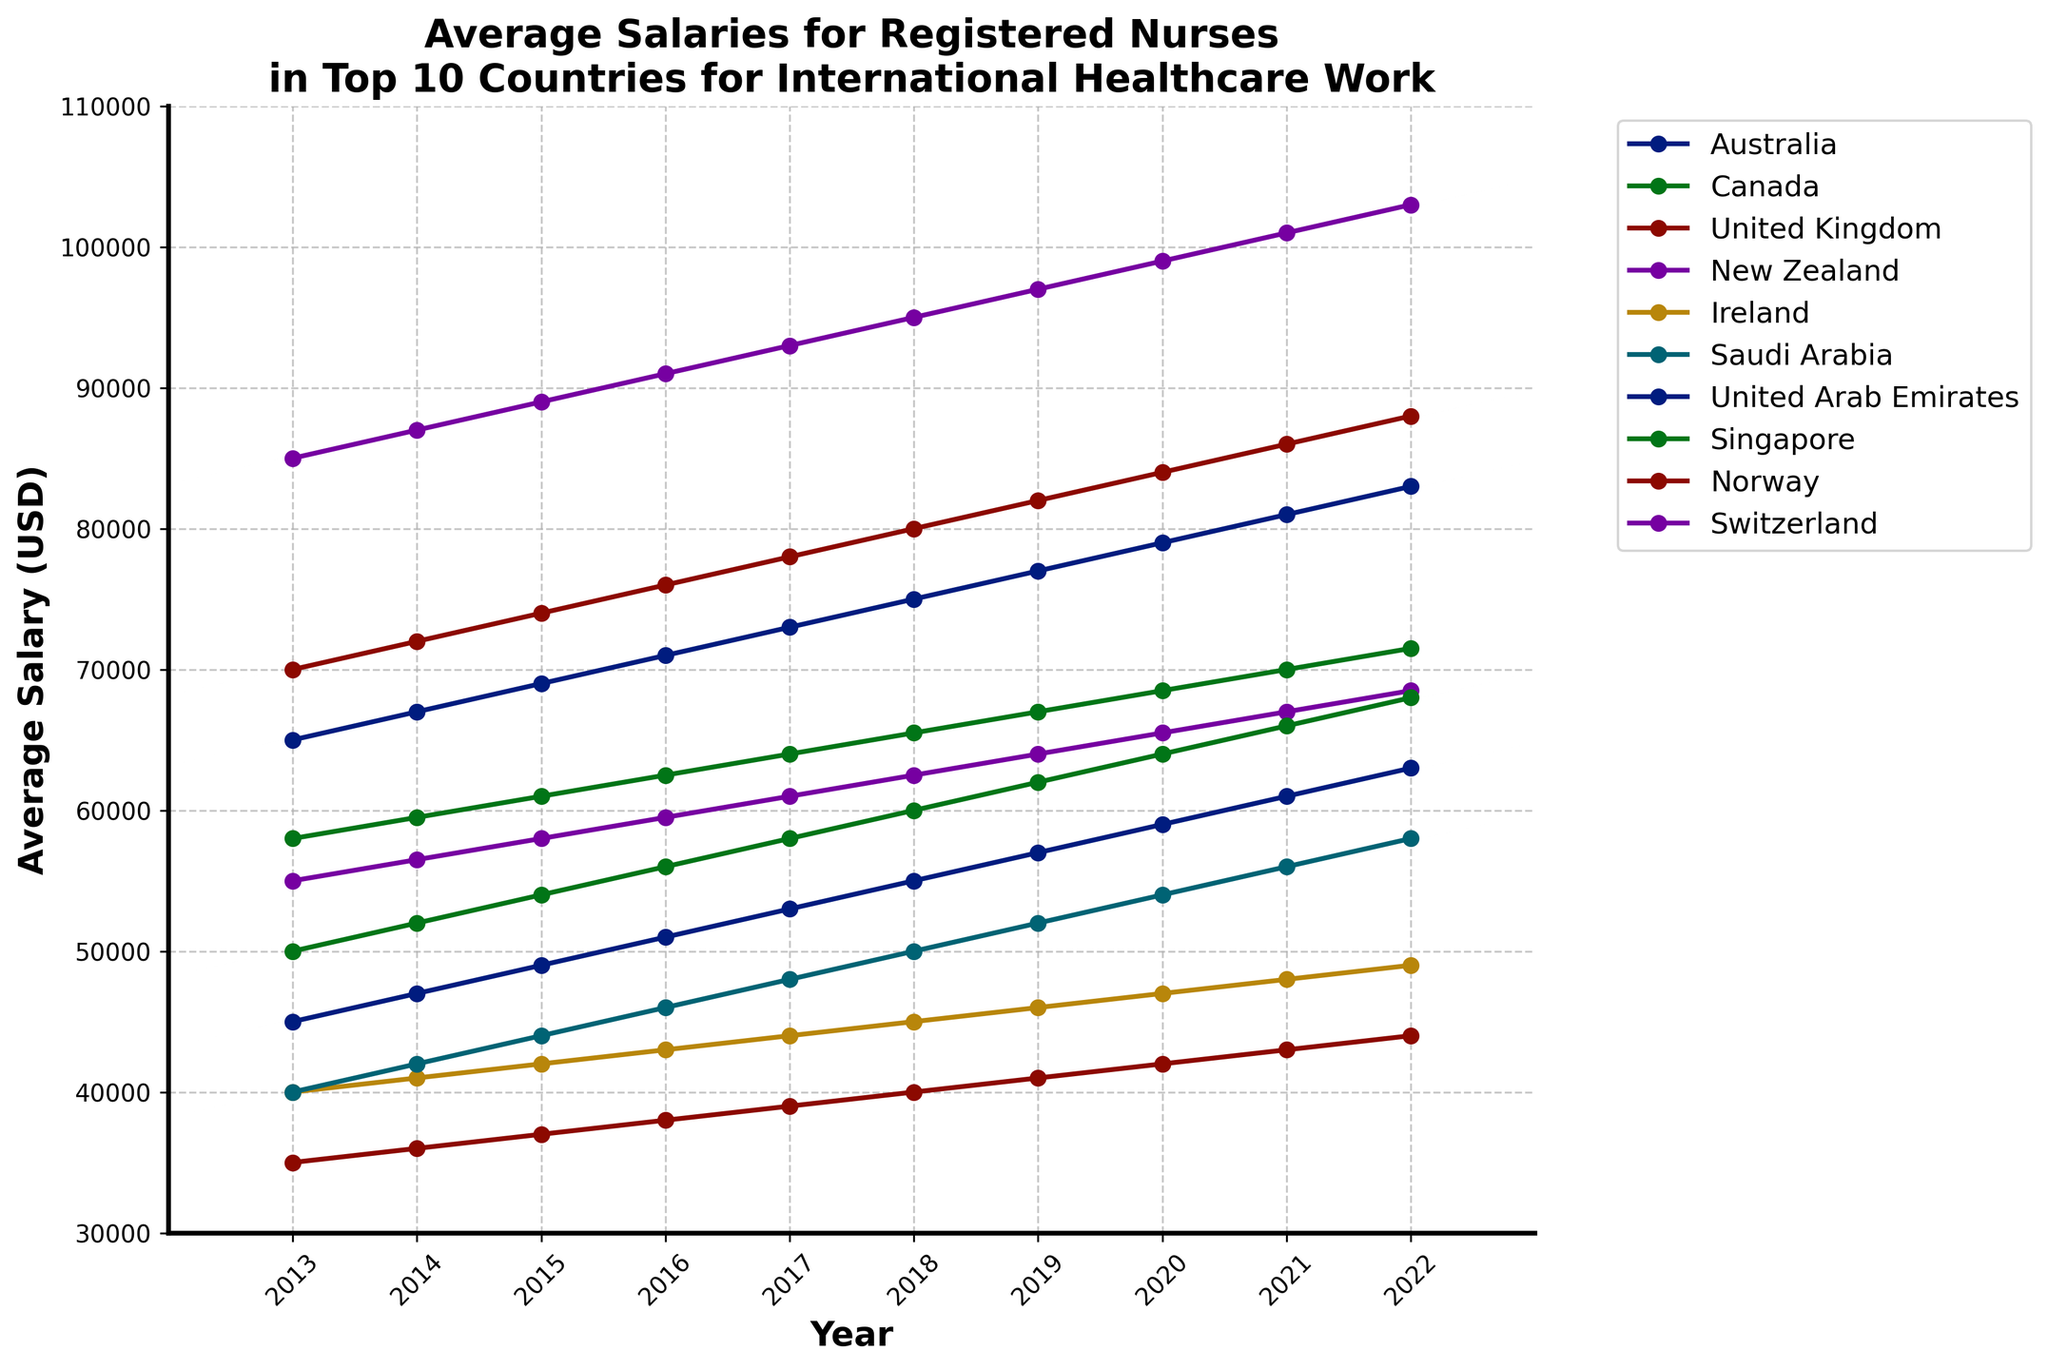What country experienced the highest average salary for registered nurses in 2022? The 2022 salaries are provided for all the countries. By observing the lines, Switzerland has the top average salary in 2022.
Answer: Switzerland How much did the average salary for registered nurses in Canada increase from 2013 to 2022? To find this, observe the line for Canada at both 2013 and 2022. Subtract the 2013 salary ($58,000) from the 2022 salary ($71,500).
Answer: $13,500 Which country had the lowest average salary for registered nurses in 2017? Check the values corresponding to 2017 for each country and identify the lowest one. The UK had the lowest average salary of $39,000 in 2017.
Answer: United Kingdom Between which years did Norway see the highest increase in the average salary for registered nurses? Observing the slope of the line representing Norway, we see the steepest increase between 2020 and 2021 ($84,000 to $86,000).
Answer: 2020 and 2021 Which country had a consistent annual increase in average salaries without any dips? By following each line year-by-year, we see that the lines for Australia, Canada, and Norway consistently trend upwards without any dips.
Answer: Australia, Canada, and Norway How does the average salary in Singapore in 2022 compare to New Zealand in 2020? Find Singapore's average salary in 2022 ($68,000) and New Zealand's in 2020 ($65,500) and compare them.
Answer: $2,500 higher What is the difference in the average salary for registered nurses between Ireland and Saudi Arabia in 2013? Ireland's 2013 salary was $40,000, while for Saudi Arabia it was $40,000. Thus, the difference is $0.
Answer: $0 Which country had the steepest overall growth in average salary from 2013 to 2022? Calculate the difference between the 2022 and 2013 salaries for each country and identify the largest one. Switzerland had the steepest growth ($103,000 - $85,000).
Answer: Switzerland In which year did the United Kingdom surpass the $40,000 mark in average salary? Following the UK's trend line, the salary first exceeds $40,000 in 2018.
Answer: 2018 